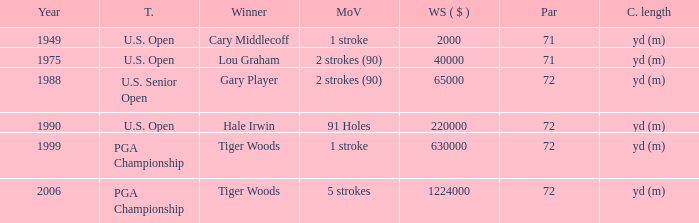When 1999 is the year how many tournaments are there? 1.0. 